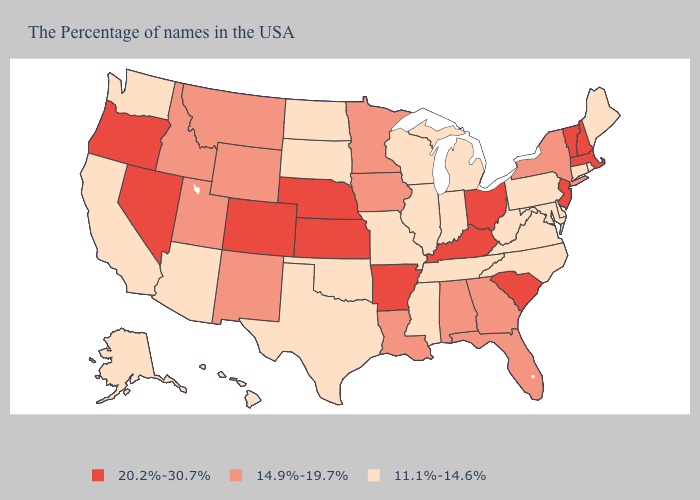Name the states that have a value in the range 20.2%-30.7%?
Write a very short answer. Massachusetts, New Hampshire, Vermont, New Jersey, South Carolina, Ohio, Kentucky, Arkansas, Kansas, Nebraska, Colorado, Nevada, Oregon. Among the states that border Kentucky , does Ohio have the lowest value?
Short answer required. No. What is the value of Arizona?
Write a very short answer. 11.1%-14.6%. Which states have the highest value in the USA?
Short answer required. Massachusetts, New Hampshire, Vermont, New Jersey, South Carolina, Ohio, Kentucky, Arkansas, Kansas, Nebraska, Colorado, Nevada, Oregon. What is the lowest value in states that border Maine?
Be succinct. 20.2%-30.7%. What is the value of Kansas?
Be succinct. 20.2%-30.7%. Among the states that border Arizona , does New Mexico have the lowest value?
Keep it brief. No. Does Alaska have the lowest value in the USA?
Short answer required. Yes. What is the value of Oklahoma?
Concise answer only. 11.1%-14.6%. Does Maine have a higher value than South Carolina?
Be succinct. No. Name the states that have a value in the range 14.9%-19.7%?
Answer briefly. New York, Florida, Georgia, Alabama, Louisiana, Minnesota, Iowa, Wyoming, New Mexico, Utah, Montana, Idaho. What is the lowest value in the USA?
Give a very brief answer. 11.1%-14.6%. What is the lowest value in states that border Alabama?
Write a very short answer. 11.1%-14.6%. Among the states that border Arkansas , does Louisiana have the lowest value?
Keep it brief. No. Among the states that border Oklahoma , does Missouri have the lowest value?
Give a very brief answer. Yes. 